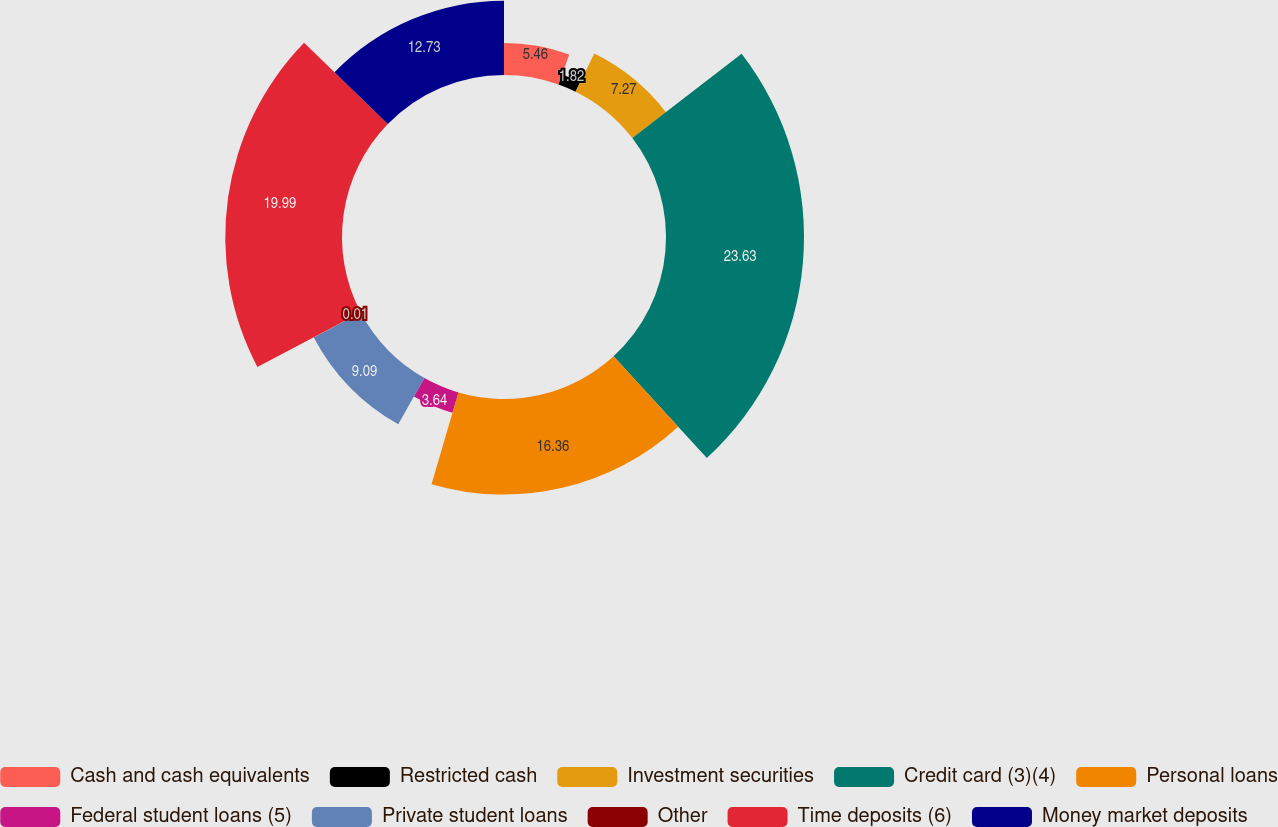<chart> <loc_0><loc_0><loc_500><loc_500><pie_chart><fcel>Cash and cash equivalents<fcel>Restricted cash<fcel>Investment securities<fcel>Credit card (3)(4)<fcel>Personal loans<fcel>Federal student loans (5)<fcel>Private student loans<fcel>Other<fcel>Time deposits (6)<fcel>Money market deposits<nl><fcel>5.46%<fcel>1.82%<fcel>7.27%<fcel>23.63%<fcel>16.36%<fcel>3.64%<fcel>9.09%<fcel>0.01%<fcel>19.99%<fcel>12.73%<nl></chart> 